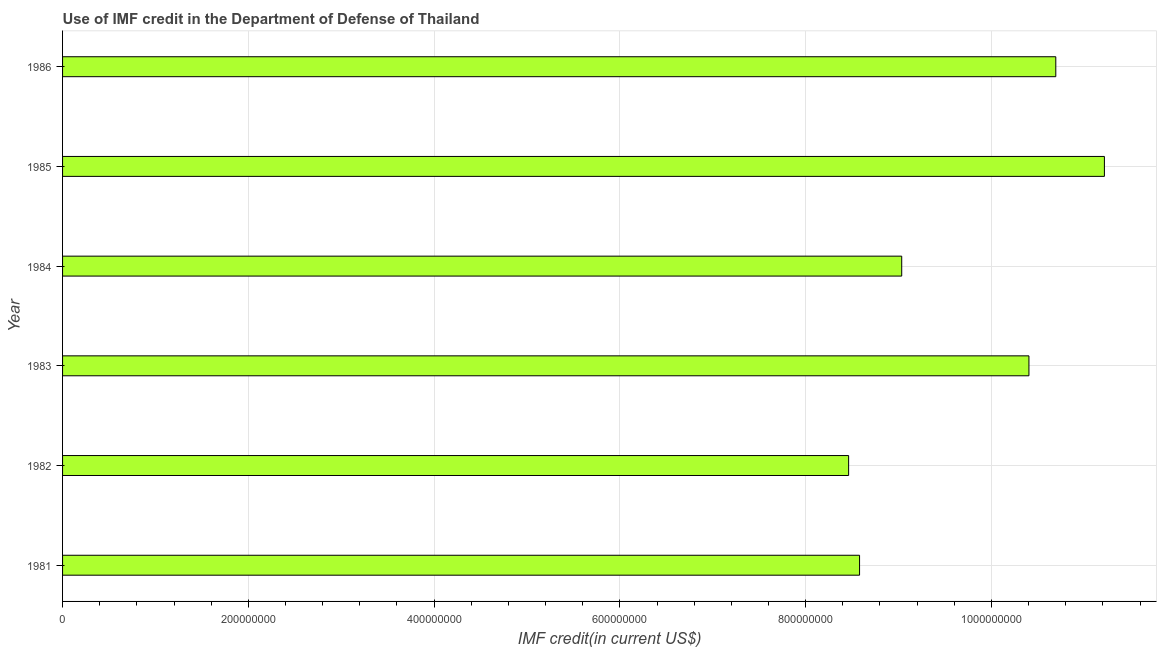Does the graph contain grids?
Your answer should be compact. Yes. What is the title of the graph?
Offer a very short reply. Use of IMF credit in the Department of Defense of Thailand. What is the label or title of the X-axis?
Keep it short and to the point. IMF credit(in current US$). What is the use of imf credit in dod in 1983?
Give a very brief answer. 1.04e+09. Across all years, what is the maximum use of imf credit in dod?
Make the answer very short. 1.12e+09. Across all years, what is the minimum use of imf credit in dod?
Make the answer very short. 8.46e+08. In which year was the use of imf credit in dod maximum?
Your answer should be compact. 1985. What is the sum of the use of imf credit in dod?
Ensure brevity in your answer.  5.84e+09. What is the difference between the use of imf credit in dod in 1982 and 1985?
Provide a succinct answer. -2.75e+08. What is the average use of imf credit in dod per year?
Make the answer very short. 9.73e+08. What is the median use of imf credit in dod?
Ensure brevity in your answer.  9.72e+08. What is the ratio of the use of imf credit in dod in 1983 to that in 1984?
Ensure brevity in your answer.  1.15. Is the use of imf credit in dod in 1983 less than that in 1985?
Provide a short and direct response. Yes. Is the difference between the use of imf credit in dod in 1984 and 1985 greater than the difference between any two years?
Provide a succinct answer. No. What is the difference between the highest and the second highest use of imf credit in dod?
Your response must be concise. 5.23e+07. Is the sum of the use of imf credit in dod in 1983 and 1986 greater than the maximum use of imf credit in dod across all years?
Give a very brief answer. Yes. What is the difference between the highest and the lowest use of imf credit in dod?
Give a very brief answer. 2.75e+08. Are all the bars in the graph horizontal?
Make the answer very short. Yes. Are the values on the major ticks of X-axis written in scientific E-notation?
Provide a short and direct response. No. What is the IMF credit(in current US$) of 1981?
Offer a terse response. 8.58e+08. What is the IMF credit(in current US$) of 1982?
Offer a very short reply. 8.46e+08. What is the IMF credit(in current US$) of 1983?
Offer a very short reply. 1.04e+09. What is the IMF credit(in current US$) in 1984?
Offer a terse response. 9.03e+08. What is the IMF credit(in current US$) of 1985?
Ensure brevity in your answer.  1.12e+09. What is the IMF credit(in current US$) in 1986?
Provide a short and direct response. 1.07e+09. What is the difference between the IMF credit(in current US$) in 1981 and 1982?
Offer a very short reply. 1.18e+07. What is the difference between the IMF credit(in current US$) in 1981 and 1983?
Keep it short and to the point. -1.82e+08. What is the difference between the IMF credit(in current US$) in 1981 and 1984?
Give a very brief answer. -4.54e+07. What is the difference between the IMF credit(in current US$) in 1981 and 1985?
Your response must be concise. -2.64e+08. What is the difference between the IMF credit(in current US$) in 1981 and 1986?
Give a very brief answer. -2.11e+08. What is the difference between the IMF credit(in current US$) in 1982 and 1983?
Ensure brevity in your answer.  -1.94e+08. What is the difference between the IMF credit(in current US$) in 1982 and 1984?
Provide a short and direct response. -5.72e+07. What is the difference between the IMF credit(in current US$) in 1982 and 1985?
Ensure brevity in your answer.  -2.75e+08. What is the difference between the IMF credit(in current US$) in 1982 and 1986?
Your answer should be very brief. -2.23e+08. What is the difference between the IMF credit(in current US$) in 1983 and 1984?
Provide a succinct answer. 1.37e+08. What is the difference between the IMF credit(in current US$) in 1983 and 1985?
Offer a very short reply. -8.12e+07. What is the difference between the IMF credit(in current US$) in 1983 and 1986?
Give a very brief answer. -2.89e+07. What is the difference between the IMF credit(in current US$) in 1984 and 1985?
Make the answer very short. -2.18e+08. What is the difference between the IMF credit(in current US$) in 1984 and 1986?
Provide a short and direct response. -1.66e+08. What is the difference between the IMF credit(in current US$) in 1985 and 1986?
Your answer should be very brief. 5.23e+07. What is the ratio of the IMF credit(in current US$) in 1981 to that in 1983?
Give a very brief answer. 0.82. What is the ratio of the IMF credit(in current US$) in 1981 to that in 1985?
Give a very brief answer. 0.77. What is the ratio of the IMF credit(in current US$) in 1981 to that in 1986?
Make the answer very short. 0.8. What is the ratio of the IMF credit(in current US$) in 1982 to that in 1983?
Make the answer very short. 0.81. What is the ratio of the IMF credit(in current US$) in 1982 to that in 1984?
Offer a terse response. 0.94. What is the ratio of the IMF credit(in current US$) in 1982 to that in 1985?
Ensure brevity in your answer.  0.76. What is the ratio of the IMF credit(in current US$) in 1982 to that in 1986?
Your response must be concise. 0.79. What is the ratio of the IMF credit(in current US$) in 1983 to that in 1984?
Ensure brevity in your answer.  1.15. What is the ratio of the IMF credit(in current US$) in 1983 to that in 1985?
Provide a short and direct response. 0.93. What is the ratio of the IMF credit(in current US$) in 1983 to that in 1986?
Make the answer very short. 0.97. What is the ratio of the IMF credit(in current US$) in 1984 to that in 1985?
Make the answer very short. 0.81. What is the ratio of the IMF credit(in current US$) in 1984 to that in 1986?
Give a very brief answer. 0.84. What is the ratio of the IMF credit(in current US$) in 1985 to that in 1986?
Your answer should be very brief. 1.05. 